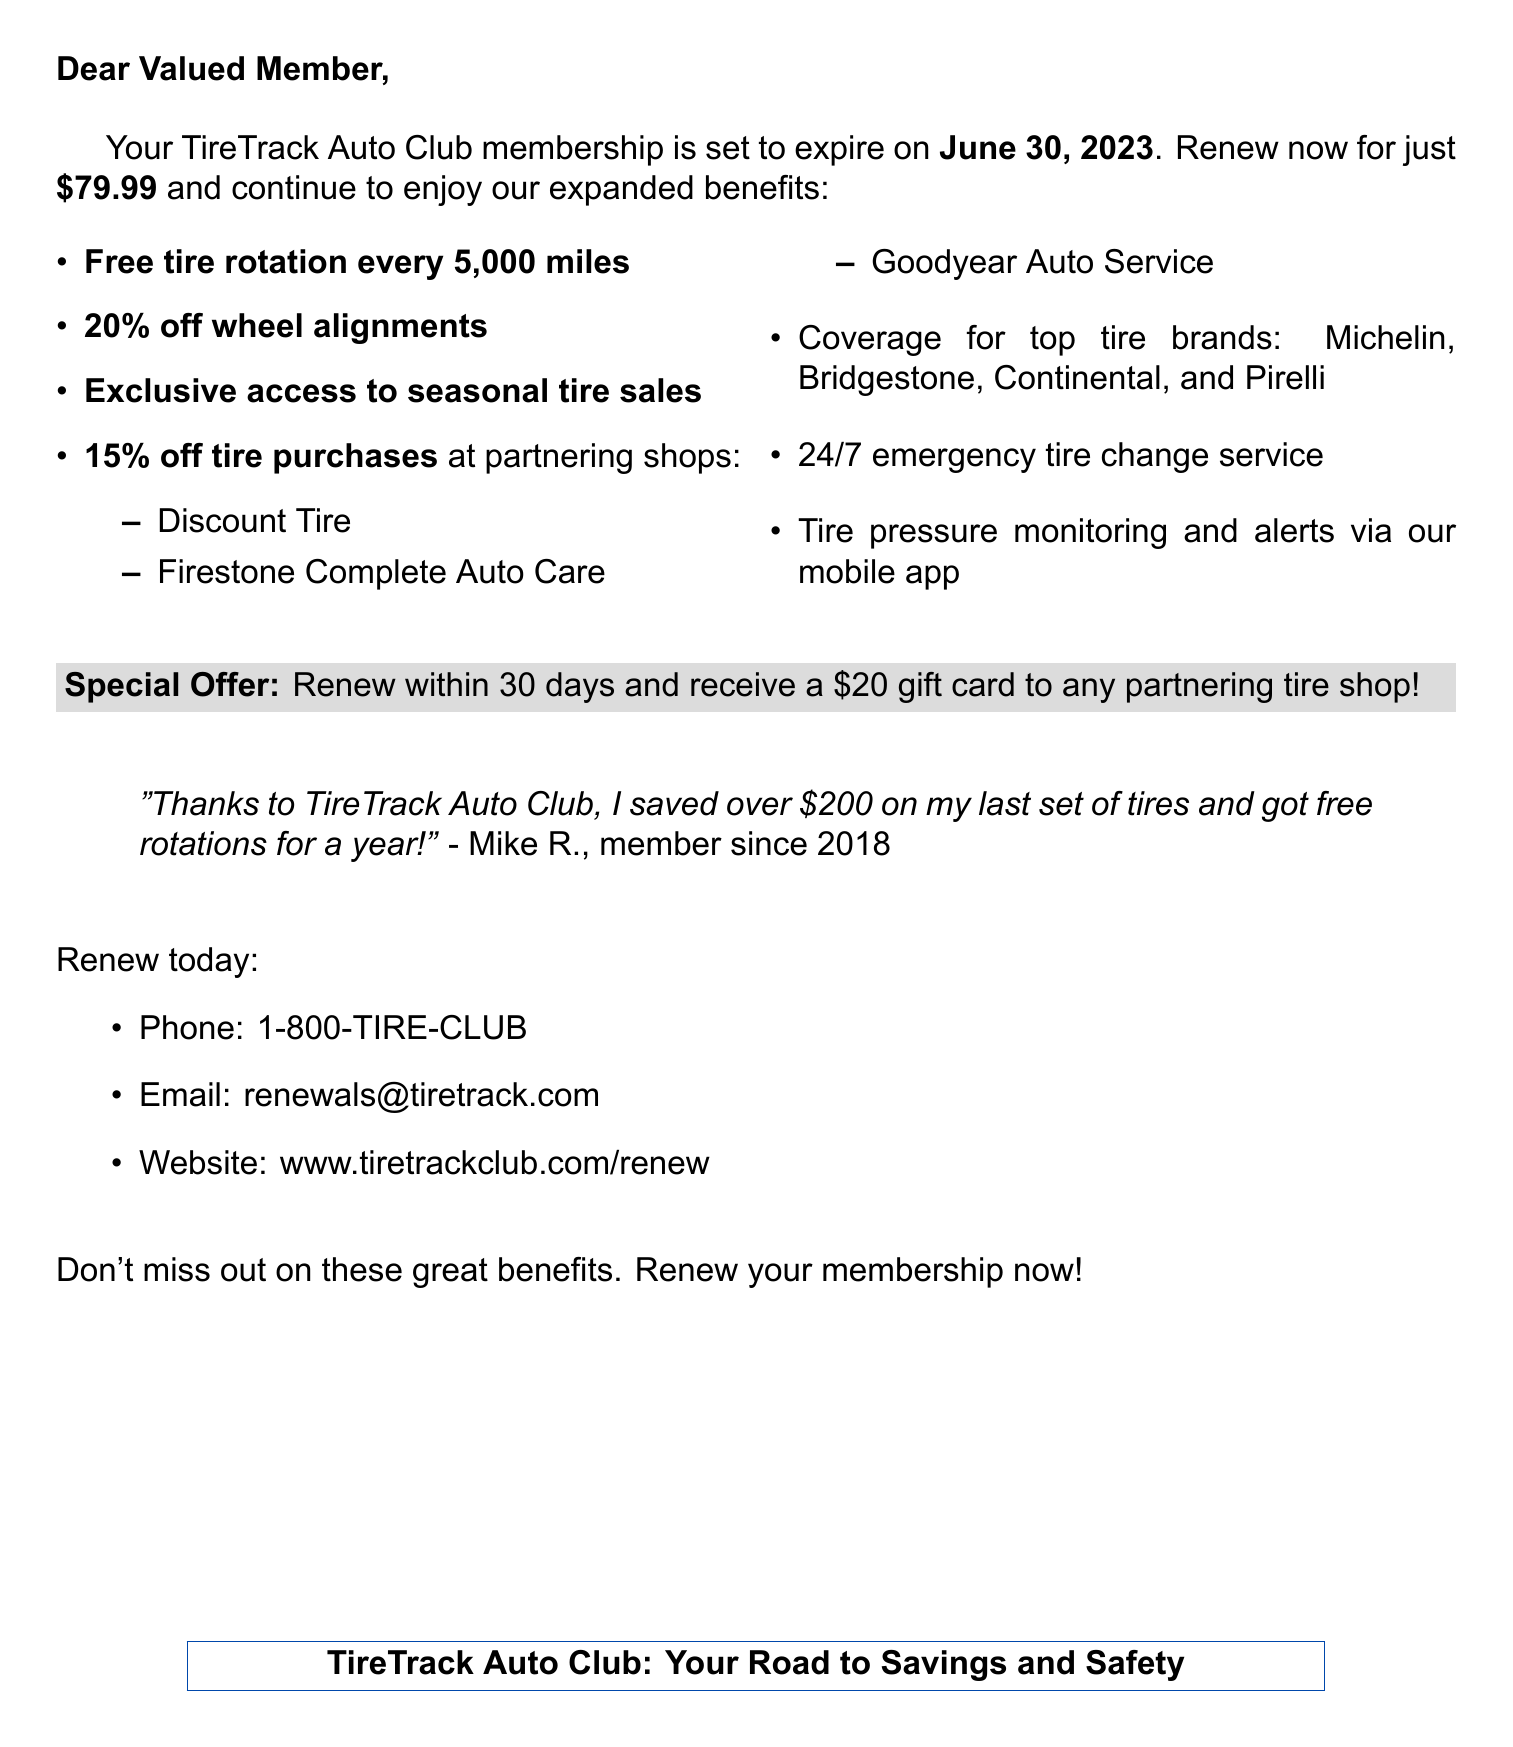What is the name of the auto club? The name of the auto club mentioned in the document is "TireTrack Auto Club."
Answer: TireTrack Auto Club When does the membership expire? The document states that the membership expiration date is "June 30, 2023."
Answer: June 30, 2023 What is the renewal fee? The renewal fee indicated in the document is "$79.99."
Answer: $79.99 What discount do members receive on tire purchases at partnering shops? The document mentions a discount of "15% off tire purchases" at partnering shops.
Answer: 15% off tire purchases Which tire brands are covered by the membership? The document lists the covered tire brands as "Michelin, Bridgestone, Continental, Pirelli."
Answer: Michelin, Bridgestone, Continental, Pirelli What special offer is provided for renewing within 30 days? The document states that if renewed within 30 days, members receive a "$20 gift card to any partnering tire shop."
Answer: $20 gift card to any partnering tire shop Which tire shops are partnering with the auto club? The partnering tire shops mentioned are "Discount Tire, Firestone Complete Auto Care, Goodyear Auto Service."
Answer: Discount Tire, Firestone Complete Auto Care, Goodyear Auto Service What service is offered 24/7? The document specifies that a "24/7 emergency tire change service" is provided.
Answer: 24/7 emergency tire change service What feature does the mobile app provide? According to the document, the mobile app provides "Tire pressure monitoring and alerts."
Answer: Tire pressure monitoring and alerts 